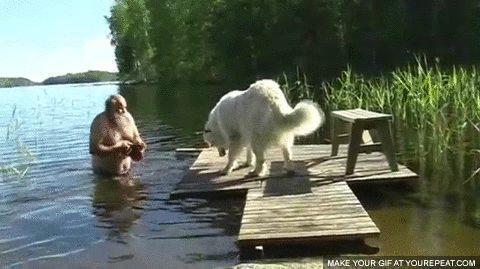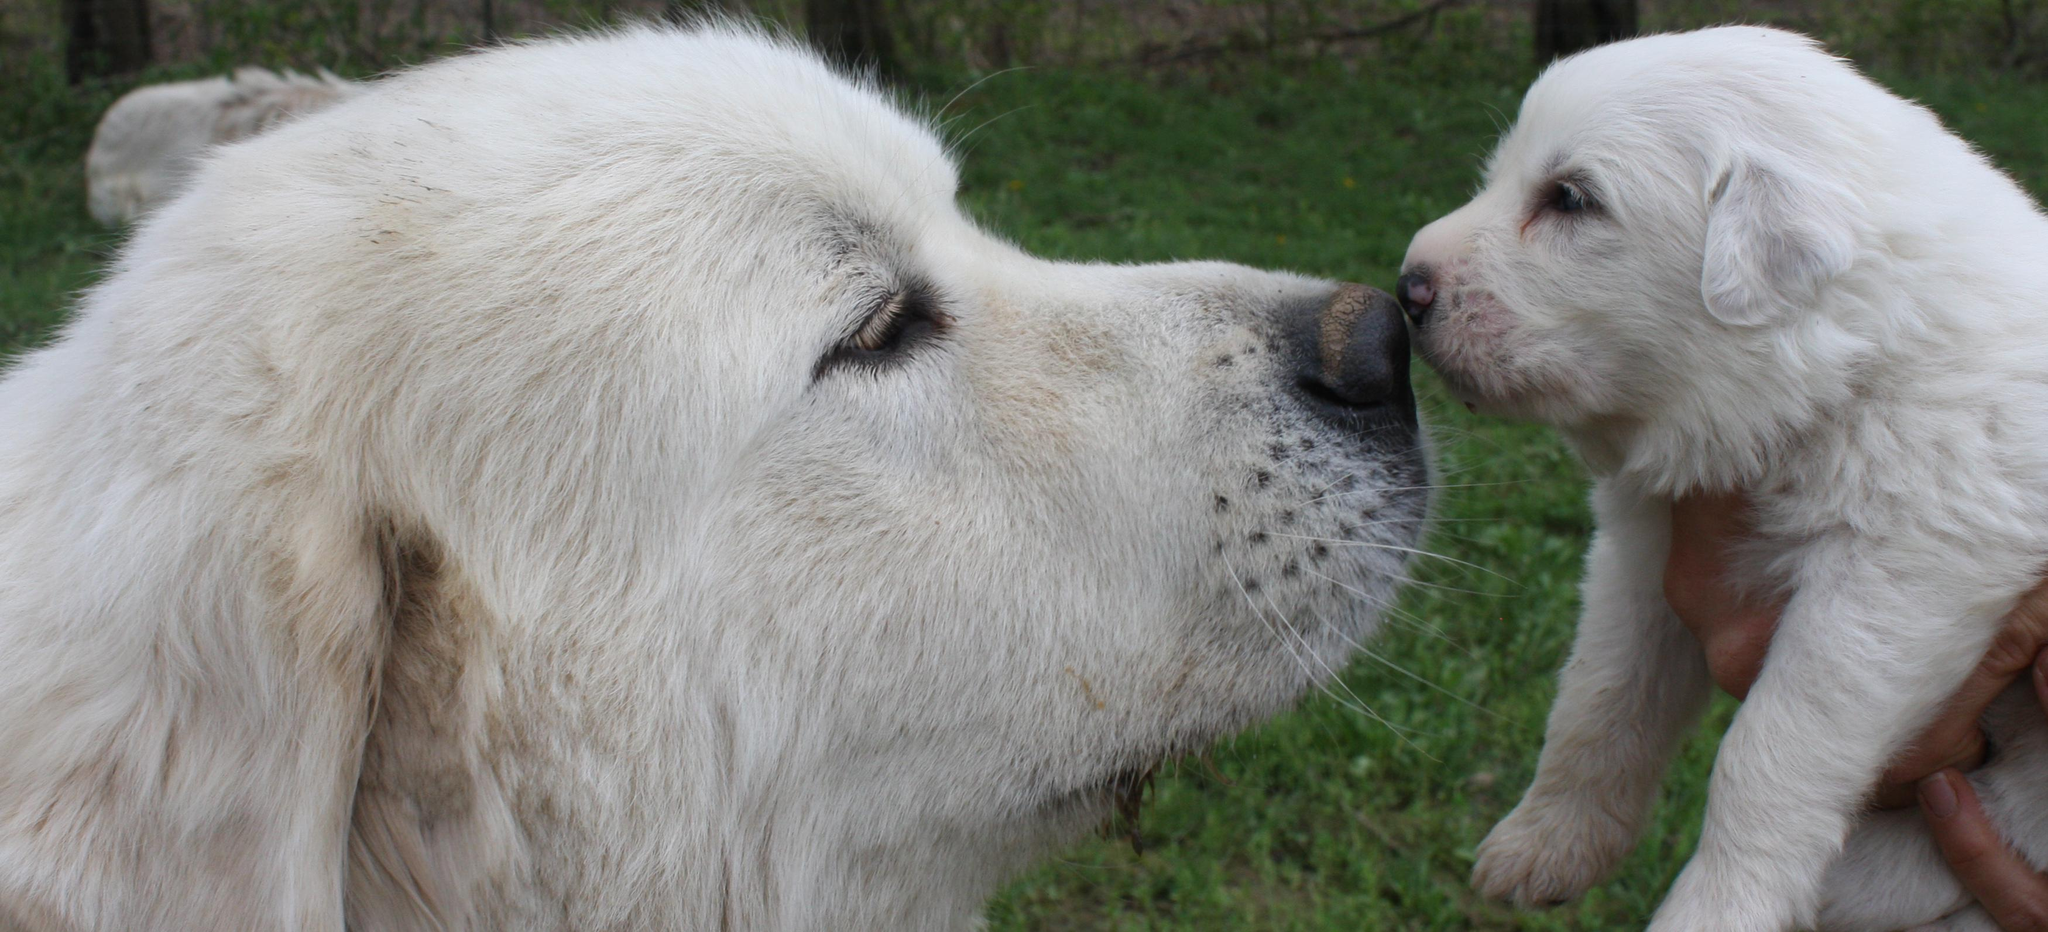The first image is the image on the left, the second image is the image on the right. Evaluate the accuracy of this statement regarding the images: "At least one dog has its mouth open.". Is it true? Answer yes or no. No. The first image is the image on the left, the second image is the image on the right. For the images displayed, is the sentence "One image includes at least twice as many white dogs as the other image." factually correct? Answer yes or no. Yes. 